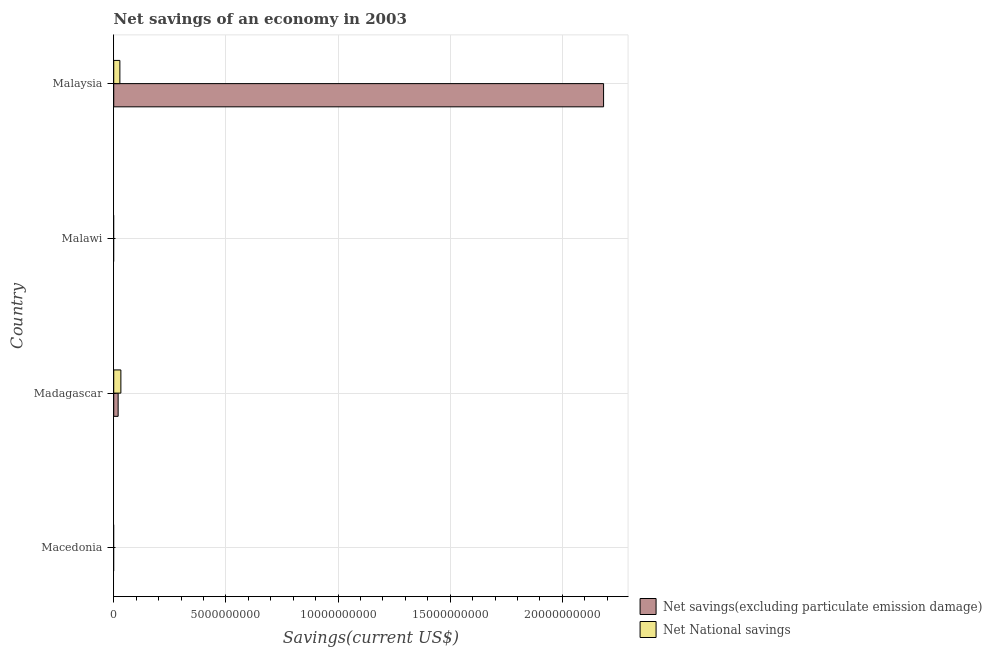How many different coloured bars are there?
Give a very brief answer. 2. Are the number of bars per tick equal to the number of legend labels?
Ensure brevity in your answer.  No. Are the number of bars on each tick of the Y-axis equal?
Offer a very short reply. No. How many bars are there on the 4th tick from the top?
Give a very brief answer. 0. What is the label of the 4th group of bars from the top?
Keep it short and to the point. Macedonia. In how many cases, is the number of bars for a given country not equal to the number of legend labels?
Offer a very short reply. 2. Across all countries, what is the maximum net savings(excluding particulate emission damage)?
Keep it short and to the point. 2.18e+1. Across all countries, what is the minimum net national savings?
Ensure brevity in your answer.  0. In which country was the net savings(excluding particulate emission damage) maximum?
Your answer should be very brief. Malaysia. What is the total net savings(excluding particulate emission damage) in the graph?
Give a very brief answer. 2.20e+1. What is the difference between the net national savings in Madagascar and that in Malaysia?
Provide a short and direct response. 4.47e+07. What is the difference between the net savings(excluding particulate emission damage) in Malaysia and the net national savings in Madagascar?
Your answer should be very brief. 2.15e+1. What is the average net savings(excluding particulate emission damage) per country?
Your answer should be compact. 5.51e+09. What is the difference between the net national savings and net savings(excluding particulate emission damage) in Madagascar?
Ensure brevity in your answer.  1.22e+08. What is the difference between the highest and the lowest net national savings?
Your response must be concise. 3.18e+08. In how many countries, is the net national savings greater than the average net national savings taken over all countries?
Your response must be concise. 2. How many bars are there?
Give a very brief answer. 4. Are all the bars in the graph horizontal?
Your answer should be very brief. Yes. How many countries are there in the graph?
Your answer should be very brief. 4. Are the values on the major ticks of X-axis written in scientific E-notation?
Your answer should be compact. No. Does the graph contain grids?
Make the answer very short. Yes. Where does the legend appear in the graph?
Your response must be concise. Bottom right. How many legend labels are there?
Make the answer very short. 2. What is the title of the graph?
Provide a succinct answer. Net savings of an economy in 2003. What is the label or title of the X-axis?
Make the answer very short. Savings(current US$). What is the label or title of the Y-axis?
Your response must be concise. Country. What is the Savings(current US$) of Net savings(excluding particulate emission damage) in Macedonia?
Offer a very short reply. 0. What is the Savings(current US$) in Net savings(excluding particulate emission damage) in Madagascar?
Offer a very short reply. 1.96e+08. What is the Savings(current US$) of Net National savings in Madagascar?
Ensure brevity in your answer.  3.18e+08. What is the Savings(current US$) in Net savings(excluding particulate emission damage) in Malaysia?
Ensure brevity in your answer.  2.18e+1. What is the Savings(current US$) in Net National savings in Malaysia?
Make the answer very short. 2.73e+08. Across all countries, what is the maximum Savings(current US$) in Net savings(excluding particulate emission damage)?
Offer a terse response. 2.18e+1. Across all countries, what is the maximum Savings(current US$) in Net National savings?
Offer a very short reply. 3.18e+08. What is the total Savings(current US$) of Net savings(excluding particulate emission damage) in the graph?
Your response must be concise. 2.20e+1. What is the total Savings(current US$) in Net National savings in the graph?
Provide a succinct answer. 5.92e+08. What is the difference between the Savings(current US$) of Net savings(excluding particulate emission damage) in Madagascar and that in Malaysia?
Your response must be concise. -2.16e+1. What is the difference between the Savings(current US$) in Net National savings in Madagascar and that in Malaysia?
Provide a succinct answer. 4.47e+07. What is the difference between the Savings(current US$) in Net savings(excluding particulate emission damage) in Madagascar and the Savings(current US$) in Net National savings in Malaysia?
Make the answer very short. -7.70e+07. What is the average Savings(current US$) of Net savings(excluding particulate emission damage) per country?
Offer a very short reply. 5.51e+09. What is the average Savings(current US$) of Net National savings per country?
Provide a short and direct response. 1.48e+08. What is the difference between the Savings(current US$) in Net savings(excluding particulate emission damage) and Savings(current US$) in Net National savings in Madagascar?
Provide a succinct answer. -1.22e+08. What is the difference between the Savings(current US$) of Net savings(excluding particulate emission damage) and Savings(current US$) of Net National savings in Malaysia?
Your answer should be compact. 2.16e+1. What is the ratio of the Savings(current US$) of Net savings(excluding particulate emission damage) in Madagascar to that in Malaysia?
Ensure brevity in your answer.  0.01. What is the ratio of the Savings(current US$) in Net National savings in Madagascar to that in Malaysia?
Your answer should be compact. 1.16. What is the difference between the highest and the lowest Savings(current US$) of Net savings(excluding particulate emission damage)?
Provide a short and direct response. 2.18e+1. What is the difference between the highest and the lowest Savings(current US$) in Net National savings?
Keep it short and to the point. 3.18e+08. 